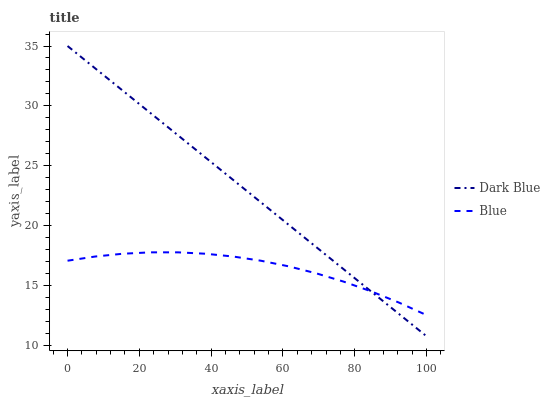Does Blue have the minimum area under the curve?
Answer yes or no. Yes. Does Dark Blue have the maximum area under the curve?
Answer yes or no. Yes. Does Dark Blue have the minimum area under the curve?
Answer yes or no. No. Is Dark Blue the smoothest?
Answer yes or no. Yes. Is Blue the roughest?
Answer yes or no. Yes. Is Dark Blue the roughest?
Answer yes or no. No. Does Dark Blue have the lowest value?
Answer yes or no. Yes. Does Dark Blue have the highest value?
Answer yes or no. Yes. Does Dark Blue intersect Blue?
Answer yes or no. Yes. Is Dark Blue less than Blue?
Answer yes or no. No. Is Dark Blue greater than Blue?
Answer yes or no. No. 